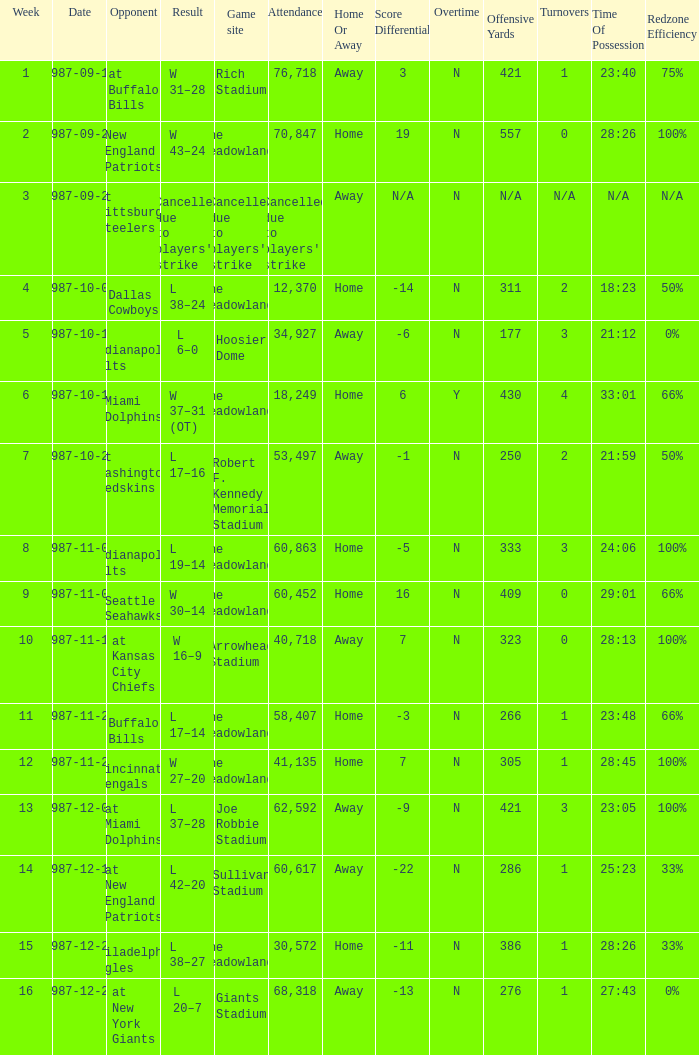Give me the full table as a dictionary. {'header': ['Week', 'Date', 'Opponent', 'Result', 'Game site', 'Attendance', 'Home Or Away', 'Score Differential', 'Overtime', 'Offensive Yards', 'Turnovers', 'Time Of Possession', 'Redzone Efficiency'], 'rows': [['1', '1987-09-13', 'at Buffalo Bills', 'W 31–28', 'Rich Stadium', '76,718', 'Away', '3', 'N', '421', '1', '23:40', '75%'], ['2', '1987-09-21', 'New England Patriots', 'W 43–24', 'The Meadowlands', '70,847', 'Home', '19', 'N', '557', '0', '28:26', '100%'], ['3', '1987-09-27', 'at Pittsburgh Steelers', "Cancelled due to players' strike", "Cancelled due to players' strike", "Cancelled due to players' strike", 'Away', 'N/A', 'N', 'N/A', 'N/A', 'N/A', 'N/A'], ['4', '1987-10-04', 'Dallas Cowboys', 'L 38–24', 'The Meadowlands', '12,370', 'Home', '-14', 'N', '311', '2', '18:23', '50%'], ['5', '1987-10-11', 'at Indianapolis Colts', 'L 6–0', 'Hoosier Dome', '34,927', 'Away', '-6', 'N', '177', '3', '21:12', '0%'], ['6', '1987-10-18', 'Miami Dolphins', 'W 37–31 (OT)', 'The Meadowlands', '18,249', 'Home', '6', 'Y', '430', '4', '33:01', '66%'], ['7', '1987-10-25', 'at Washington Redskins', 'L 17–16', 'Robert F. Kennedy Memorial Stadium', '53,497', 'Away', '-1', 'N', '250', '2', '21:59', '50%'], ['8', '1987-11-01', 'Indianapolis Colts', 'L 19–14', 'The Meadowlands', '60,863', 'Home', '-5', 'N', '333', '3', '24:06', '100%'], ['9', '1987-11-09', 'Seattle Seahawks', 'W 30–14', 'The Meadowlands', '60,452', 'Home', '16', 'N', '409', '0', '29:01', '66%'], ['10', '1987-11-15', 'at Kansas City Chiefs', 'W 16–9', 'Arrowhead Stadium', '40,718', 'Away', '7', 'N', '323', '0', '28:13', '100%'], ['11', '1987-11-22', 'Buffalo Bills', 'L 17–14', 'The Meadowlands', '58,407', 'Home', '-3', 'N', '266', '1', '23:48', '66%'], ['12', '1987-11-29', 'Cincinnati Bengals', 'W 27–20', 'The Meadowlands', '41,135', 'Home', '7', 'N', '305', '1', '28:45', '100%'], ['13', '1987-12-07', 'at Miami Dolphins', 'L 37–28', 'Joe Robbie Stadium', '62,592', 'Away', '-9', 'N', '421', '3', '23:05', '100%'], ['14', '1987-12-13', 'at New England Patriots', 'L 42–20', 'Sullivan Stadium', '60,617', 'Away', '-22', 'N', '286', '1', '25:23', '33%'], ['15', '1987-12-20', 'Philadelphia Eagles', 'L 38–27', 'The Meadowlands', '30,572', 'Home', '-11', 'N', '386', '1', '28:26', '33%'], ['16', '1987-12-27', 'at New York Giants', 'L 20–7', 'Giants Stadium', '68,318', 'Away', '-13', 'N', '276', '1', '27:43', '0%']]} Who did the Jets play in their post-week 15 game? At new york giants. 